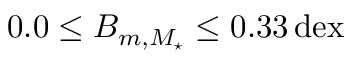<formula> <loc_0><loc_0><loc_500><loc_500>0 . 0 \leq B _ { m , M _ { ^ { * } } } \leq 0 . 3 3 \, d e x</formula> 